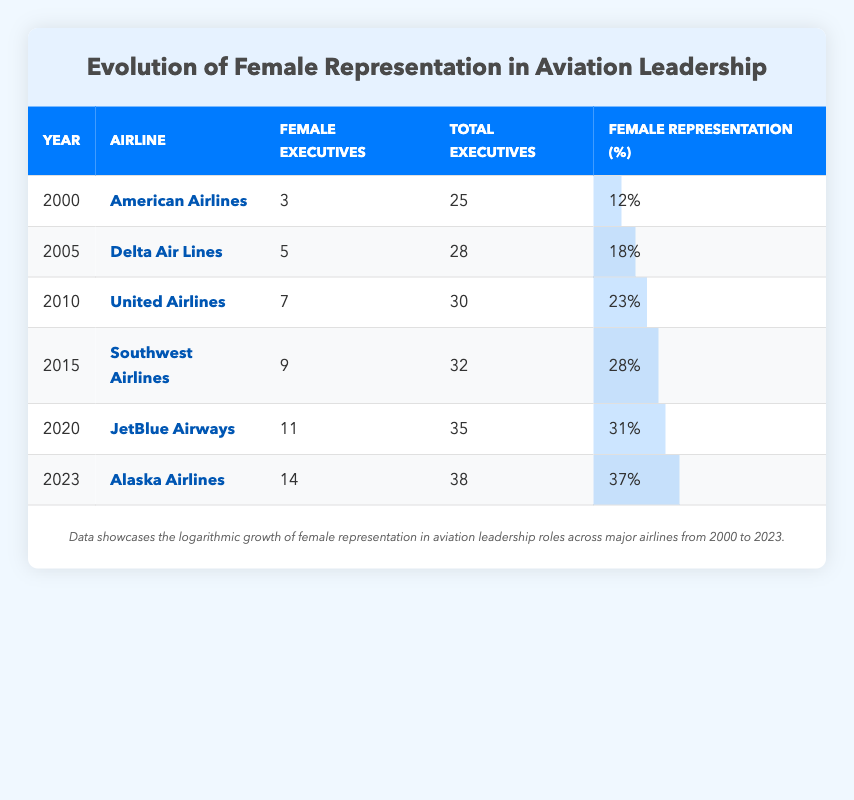What was the female representation in leadership at American Airlines in 2000? Referring to the table, American Airlines had 3 female executives out of a total of 25 executives in the year 2000. To find the female representation, we take (3/25) * 100 = 12%.
Answer: 12% Which airline had the highest female representation in 2023? Reviewing the table, Alaska Airlines in 2023 has the highest female representation with 14 female executives out of 38 total executives, which is 37%.
Answer: Alaska Airlines What is the average percentage of female representation from 2000 to 2023? To calculate the average percentage of female representation, we add the values (12, 18, 23, 28, 31, 37) and divide by 6: (12 + 18 + 23 + 28 + 31 + 37) = 149, and 149/6 = 24.83%.
Answer: Approximately 24.83% Did Delta Air Lines have a higher percentage of female executives than United Airlines in 2010? In 2010, United Airlines had a female representation of 23%, while Delta Air Lines had only 18% in 2005. Since 23% > 18%, it can be concluded that United Airlines had a higher percentage.
Answer: Yes What was the increase in female representation from 2000 to 2023? To find the increase, we subtract the female representation in 2000 (12%) from that in 2023 (37%). The calculation is (37 - 12) = 25%. This shows a significant increase in female representation over the years.
Answer: 25% Which airline experienced the largest increase in female representation between any two consecutive years? By analyzing the differences in female representation percentages between consecutive years: 2000-2005 (6%), 2005-2010 (5%), 2010-2015 (5%), 2015-2020 (3%), and 2020-2023 (6%). The largest increase is between 2010-2015 and 2020-2023, both with 6%.
Answer: 6% Was there a year when the female representation reached exactly 30%? Referring to the table, female representation peaked at 31% in 2020, and there is no entry for exactly 30%. Thus, the answer is negative.
Answer: No 